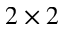<formula> <loc_0><loc_0><loc_500><loc_500>2 \times 2</formula> 